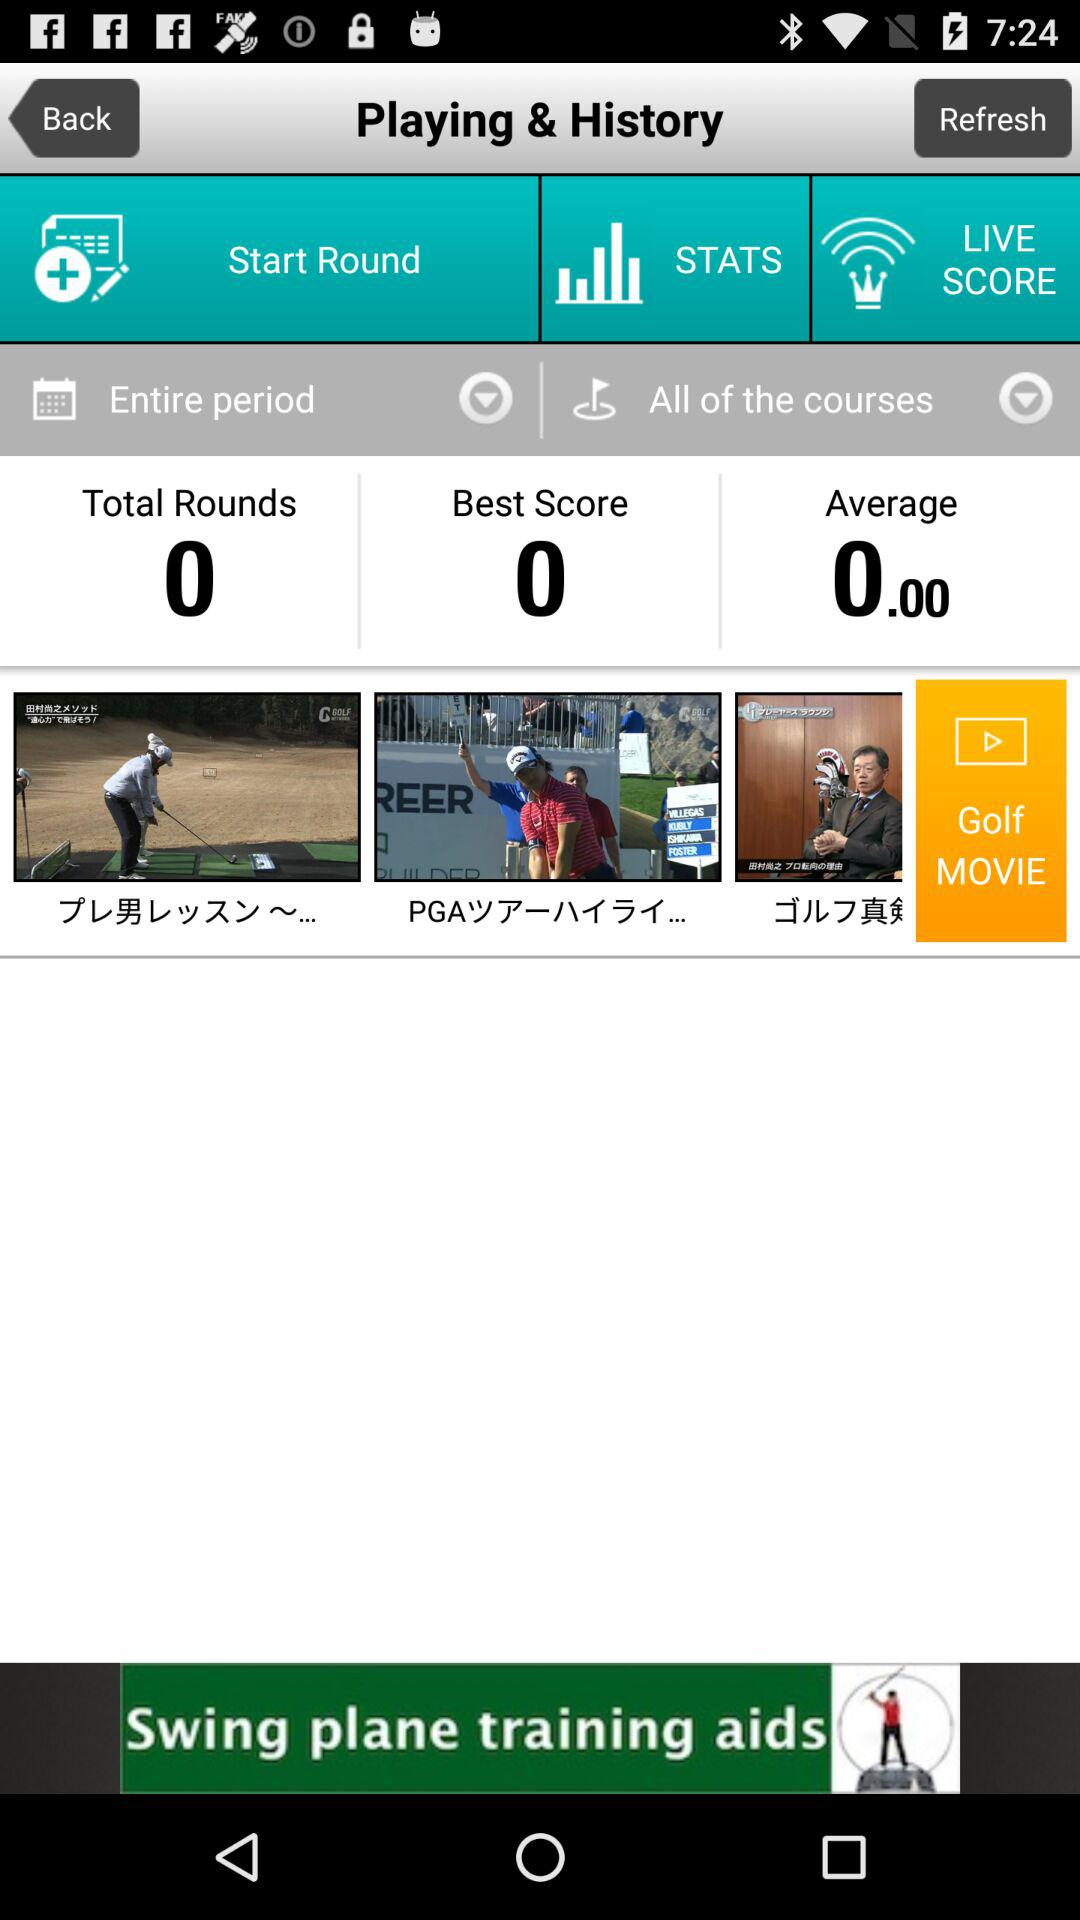How many rounds in total are there? There are 0 rounds in total. 